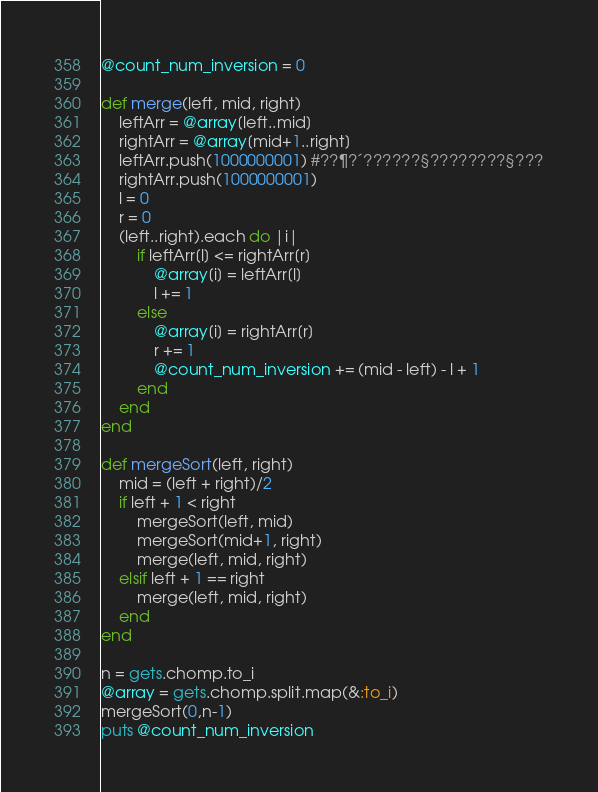<code> <loc_0><loc_0><loc_500><loc_500><_Ruby_>@count_num_inversion = 0

def merge(left, mid, right)
    leftArr = @array[left..mid]
    rightArr = @array[mid+1..right]
    leftArr.push(1000000001) #??¶?´??????§????????§???
    rightArr.push(1000000001)
    l = 0
    r = 0
    (left..right).each do |i|
        if leftArr[l] <= rightArr[r]
            @array[i] = leftArr[l]
            l += 1
        else
            @array[i] = rightArr[r]
            r += 1
            @count_num_inversion += (mid - left) - l + 1 
        end
    end
end

def mergeSort(left, right)
    mid = (left + right)/2
    if left + 1 < right
        mergeSort(left, mid)
        mergeSort(mid+1, right)
        merge(left, mid, right)
    elsif left + 1 == right
        merge(left, mid, right)
    end
end

n = gets.chomp.to_i
@array = gets.chomp.split.map(&:to_i)
mergeSort(0,n-1)
puts @count_num_inversion</code> 